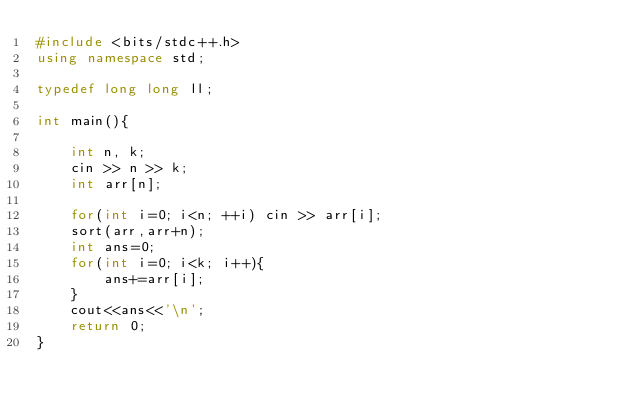<code> <loc_0><loc_0><loc_500><loc_500><_C++_>#include <bits/stdc++.h>
using namespace std;

typedef long long ll;

int main(){

    int n, k;
    cin >> n >> k;
    int arr[n];

    for(int i=0; i<n; ++i) cin >> arr[i];
    sort(arr,arr+n);
    int ans=0;
    for(int i=0; i<k; i++){
        ans+=arr[i];
    }
    cout<<ans<<'\n';
    return 0;
}
</code> 